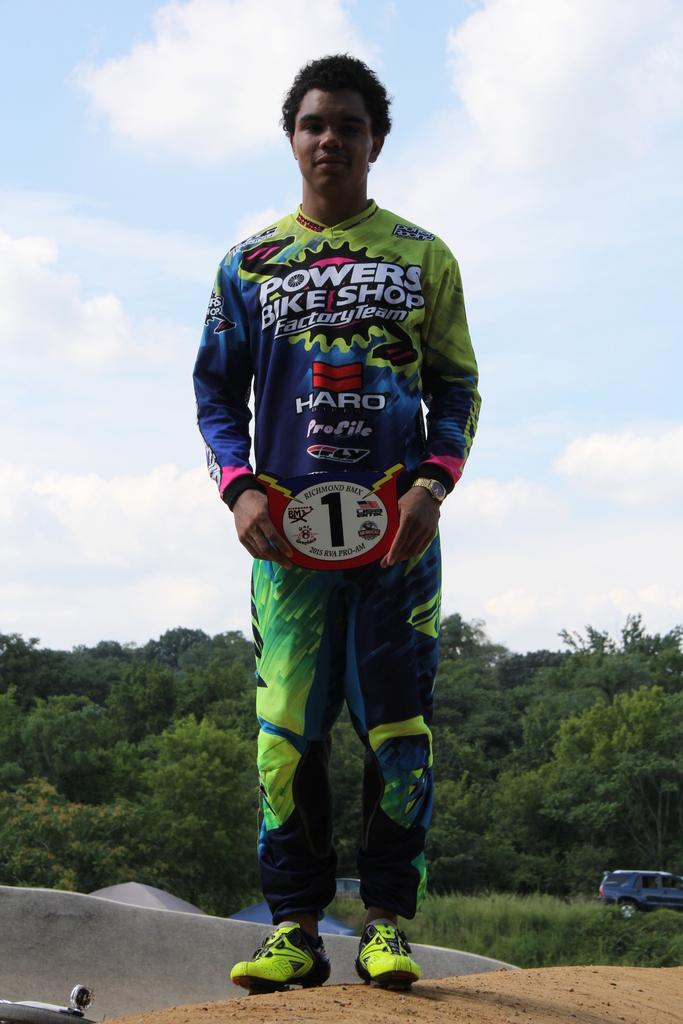Provide a one-sentence caption for the provided image. A young man wears colorful clothes sponsored by Powers Bike Shop. 